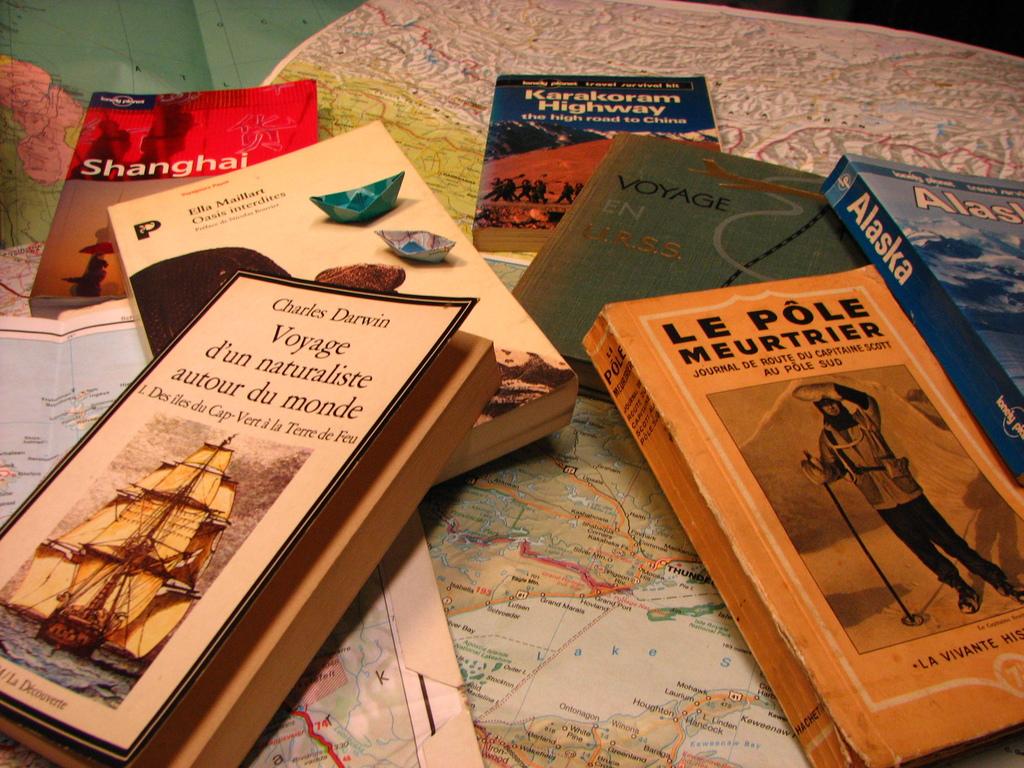Who wrote the white book at the front of the picture?
Your response must be concise. Charles darwin. 